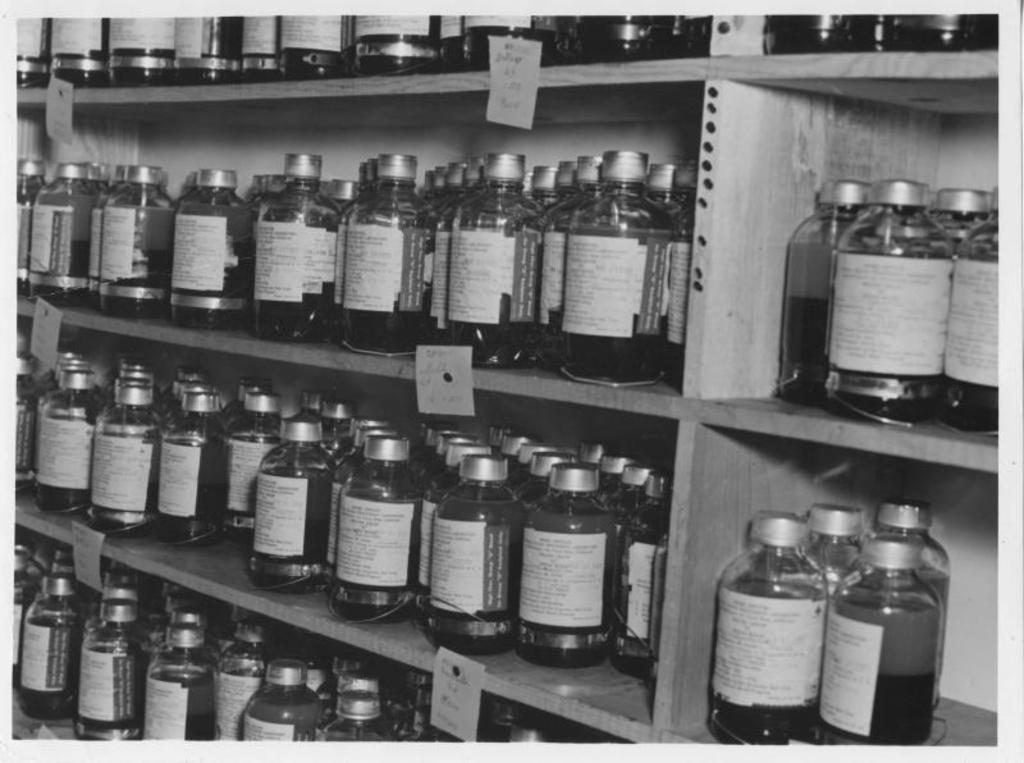What is the color scheme of the image? The image is black and white. What type of furniture is visible in the image? There are shelves in the image. What items are on the shelves? There are bottles on the shelves. What is inside the bottles? The bottles contain liquid. How many children are playing in the room in the image? There is no room or children present in the image; it is a black and white image of shelves with bottles containing liquid. 